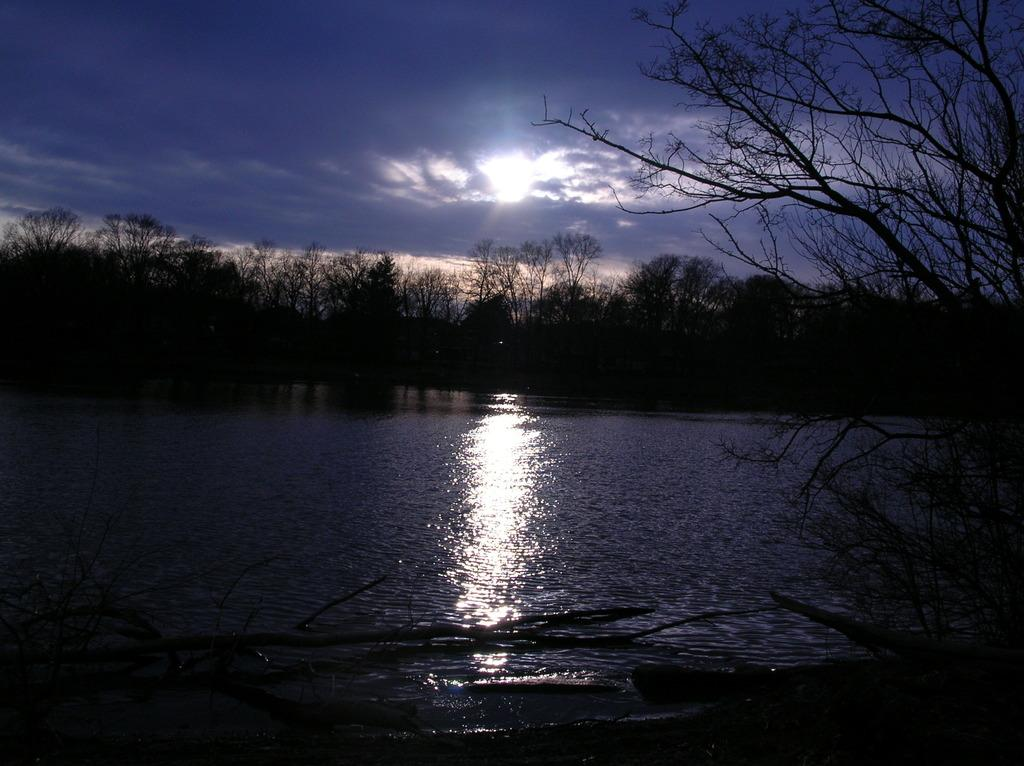What type of natural environment is depicted in the image? The image features many trees, suggesting a forest or wooded area. What body of water is visible at the bottom of the image? There is water or a river at the bottom of the image. What can be seen in the sky in the image? The sky is visible at the top of the image, and clouds are present. What celestial body is visible in the image? The sun is visible in the image. What type of property is being sold in the image? There is no indication of any property being sold in the image; it primarily features natural elements such as trees, water, and the sky. 